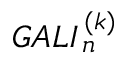Convert formula to latex. <formula><loc_0><loc_0><loc_500><loc_500>G A L I _ { \, n } ^ { \, ( k ) }</formula> 